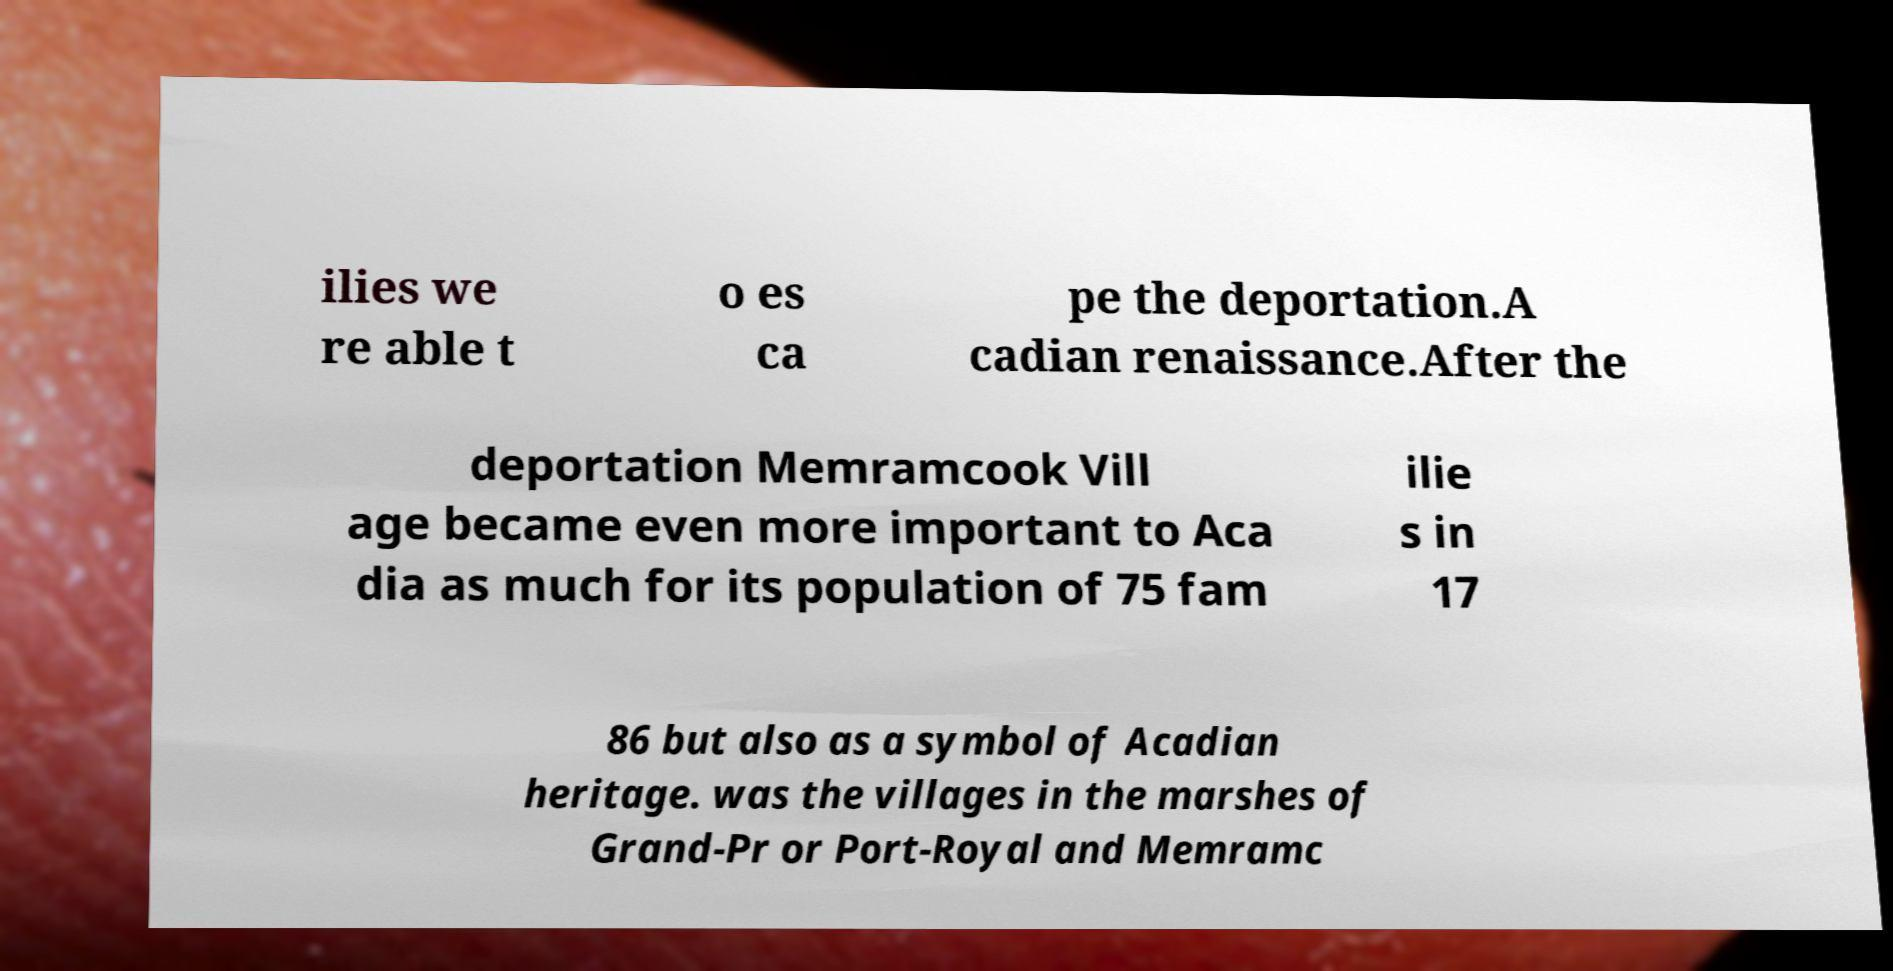Could you extract and type out the text from this image? ilies we re able t o es ca pe the deportation.A cadian renaissance.After the deportation Memramcook Vill age became even more important to Aca dia as much for its population of 75 fam ilie s in 17 86 but also as a symbol of Acadian heritage. was the villages in the marshes of Grand-Pr or Port-Royal and Memramc 